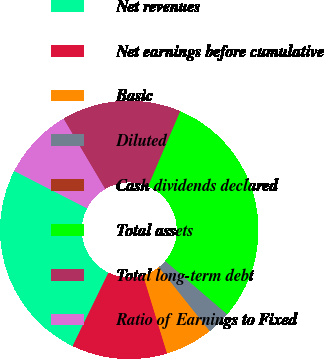Convert chart. <chart><loc_0><loc_0><loc_500><loc_500><pie_chart><fcel>Net revenues<fcel>Net earnings before cumulative<fcel>Basic<fcel>Diluted<fcel>Cash dividends declared<fcel>Total assets<fcel>Total long-term debt<fcel>Ratio of Earnings to Fixed<nl><fcel>25.32%<fcel>11.95%<fcel>5.97%<fcel>2.99%<fcel>0.0%<fcel>29.87%<fcel>14.94%<fcel>8.96%<nl></chart> 